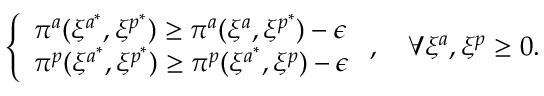<formula> <loc_0><loc_0><loc_500><loc_500>\left \{ \begin{array} { l l } { \pi ^ { a } ( \xi ^ { a ^ { * } } , \xi ^ { p ^ { * } } ) \geq \pi ^ { a } ( \xi ^ { a } , \xi ^ { p ^ { * } } ) - \epsilon } \\ { \pi ^ { p } ( \xi ^ { a ^ { * } } , \xi ^ { p ^ { * } } ) \geq \pi ^ { p } ( \xi ^ { a ^ { * } } , \xi ^ { p } ) - \epsilon } \end{array} , \quad \forall \xi ^ { a } , \xi ^ { p } \geq 0 .</formula> 